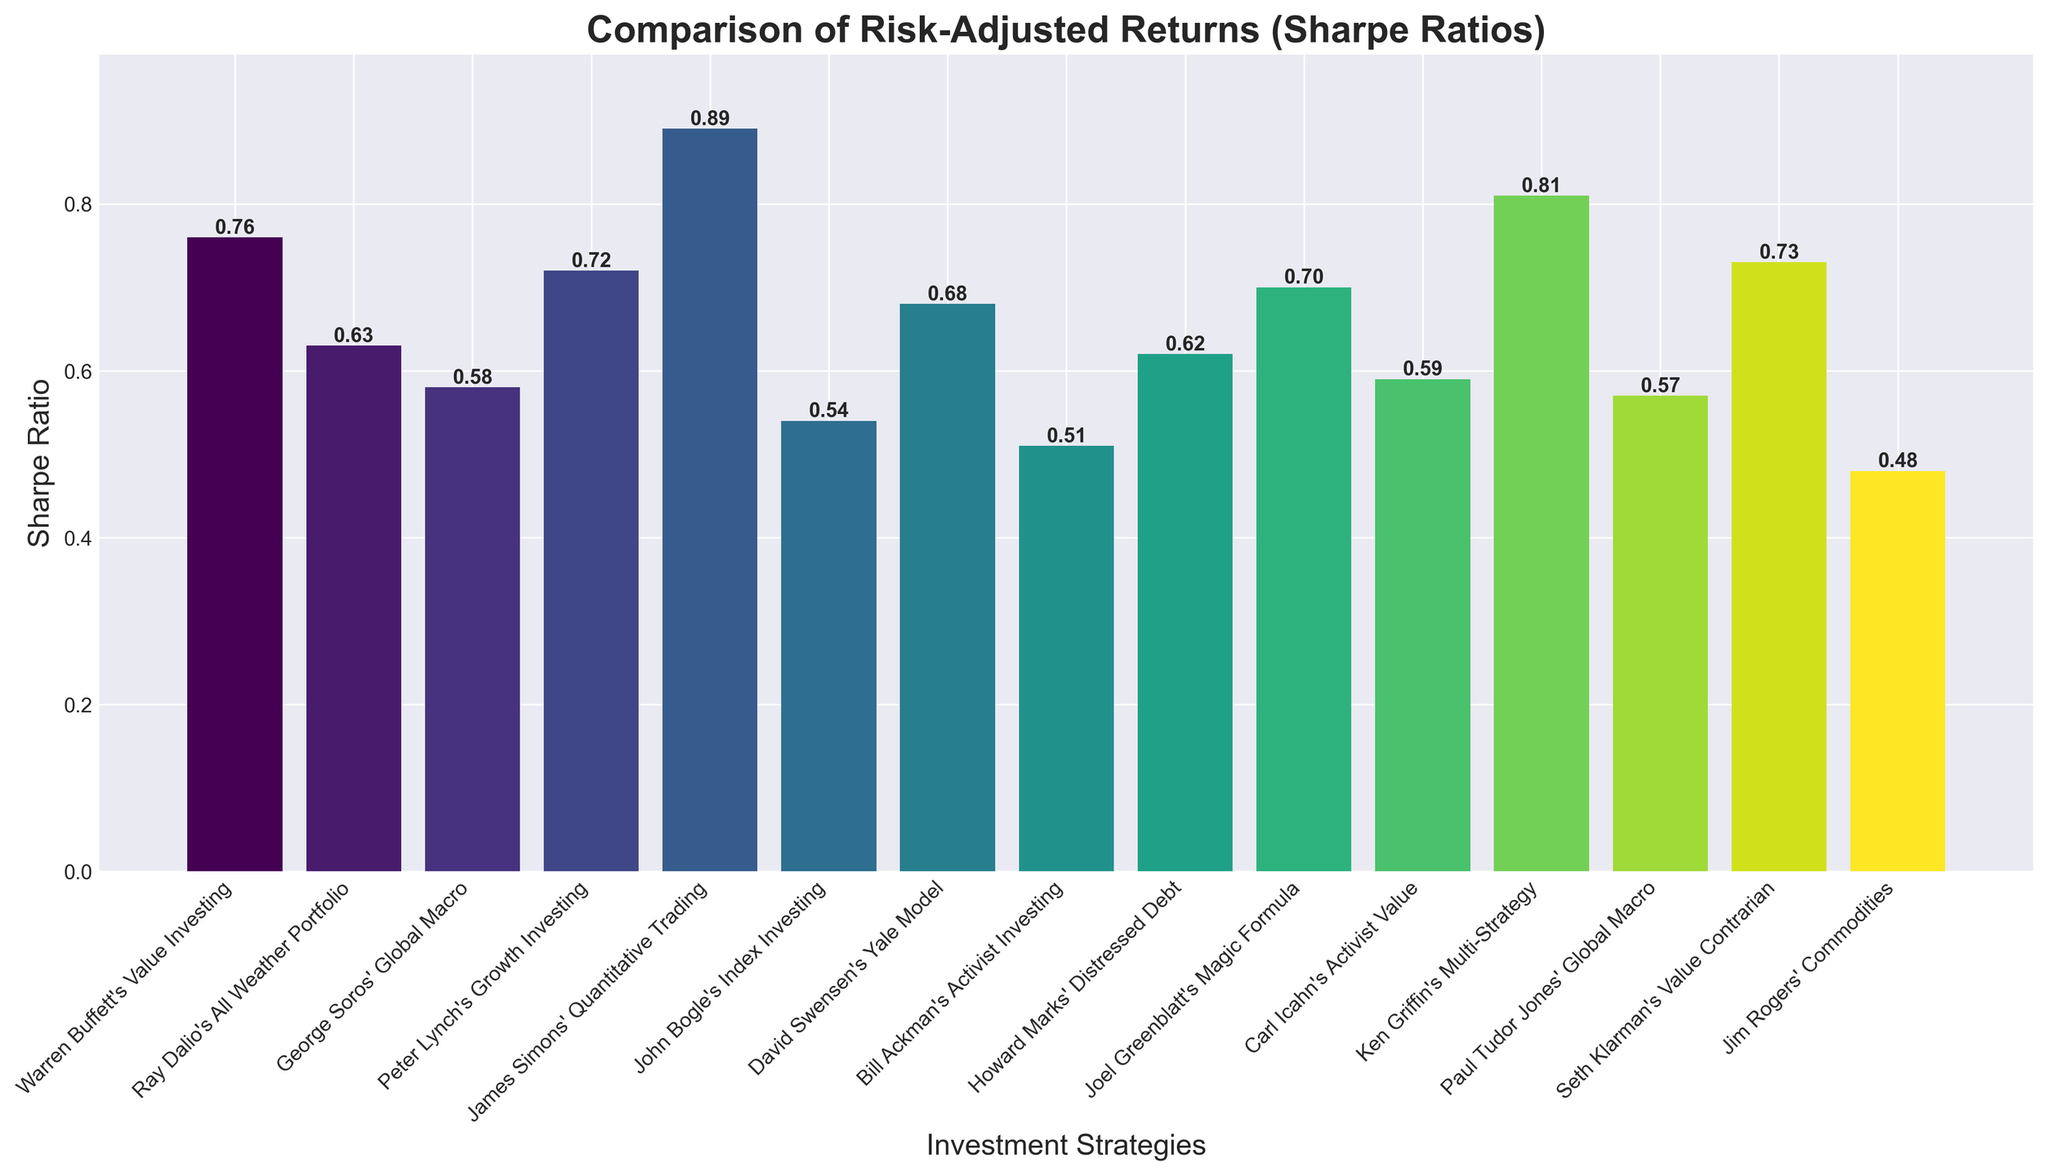How many strategies have a Sharpe ratio higher than 0.70? We can count the bars with a height (Sharpe ratio) greater than 0.70. These strategies are "James Simons' Quantitative Trading" (0.89), "Ken Griffin's Multi-Strategy" (0.81), "Warren Buffett's Value Investing" (0.76), "Peter Lynch's Growth Investing" (0.72), and "Seth Klarman's Value Contrarian" (0.73). There are five strategies in total.
Answer: 5 Which investment strategy has the lowest Sharpe ratio and what is its value? Among the bars in the chart, the shortest one represents the strategy with the lowest Sharpe ratio, which is "Jim Rogers' Commodities" with the value of 0.48.
Answer: Jim Rogers' Commodities, 0.48 Is the Sharpe ratio of "Peter Lynch's Growth Investing" closer to "Warren Buffett's Value Investing" or "Ken Griffin's Multi-Strategy"? Comparing the Sharpe ratios: "Peter Lynch's Growth Investing" is 0.72, "Warren Buffett's Value Investing" is 0.76, and "Ken Griffin's Multi-Strategy" is 0.81. The difference between Peter Lynch and Warren Buffett is 0.76 - 0.72 = 0.04, and the difference between Peter Lynch and Ken Griffin is 0.81 - 0.72 = 0.09. Hence, it is closer to Warren Buffett's strategy.
Answer: Warren Buffett's Value Investing What is the average Sharpe ratio of the top three strategies? The top three strategies by Sharpe ratio are "James Simons' Quantitative Trading" (0.89), "Ken Griffin's Multi-Strategy" (0.81), and "Warren Buffett's Value Investing" (0.76). The average is calculated as (0.89 + 0.81 + 0.76) / 3 = 2.46 / 3 = 0.82.
Answer: 0.82 How does the Sharpe ratio of "John Bogle's Index Investing" compare to the median Sharpe ratio of all strategies? First, sort all Sharpe ratios: 0.48, 0.51, 0.54, 0.57, 0.58, 0.59, 0.62, 0.63, 0.68, 0.70, 0.72, 0.73, 0.76, 0.81, 0.89. The median is the middle value, which is the 8th value, 0.63. The Sharpe ratio of "John Bogle's Index Investing" is 0.54, which is less than the median value.
Answer: Less than the median What is the combined Sharpe ratio of "Ray Dalio's All Weather Portfolio" and "David Swensen's Yale Model"? Look at the bars corresponding to these strategies: "Ray Dalio's All Weather Portfolio" is 0.63 and "David Swensen's Yale Model" is 0.68. Adding them gives 0.63 + 0.68 = 1.31.
Answer: 1.31 Which two strategies have the most similar Sharpe ratios and what are those values? By closely comparing the heights of the bars, "Paul Tudor Jones' Global Macro" and "George Soros' Global Macro" stand out as similar. Their values are 0.57 and 0.58, respectively.
Answer: Paul Tudor Jones' Global Macro, 0.57; George Soros' Global Macro, 0.58 